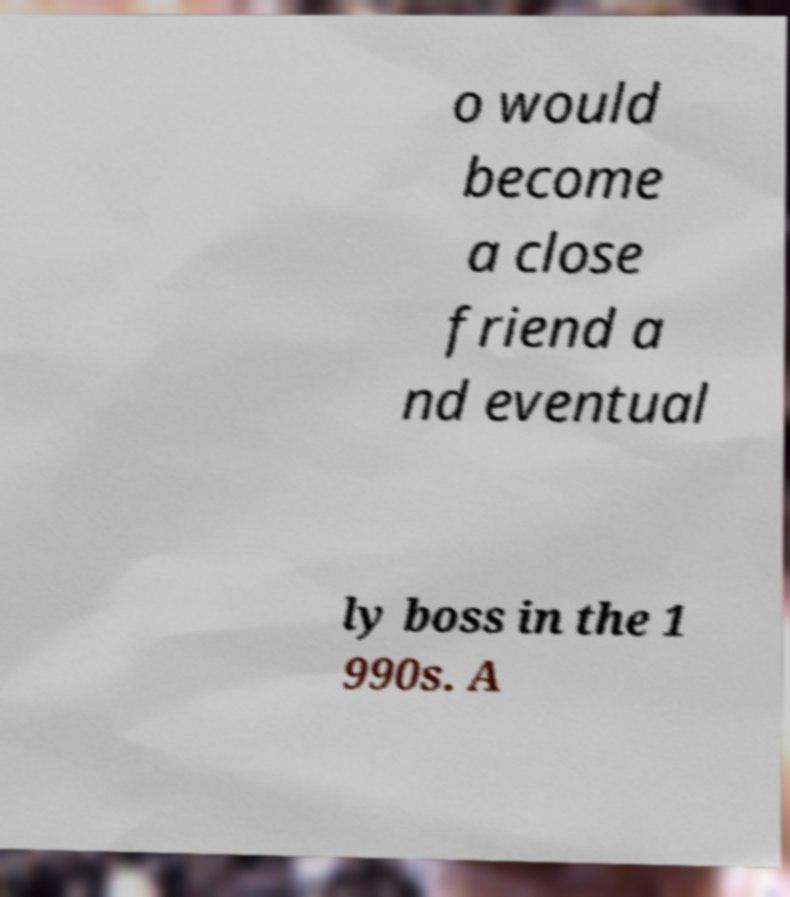Can you accurately transcribe the text from the provided image for me? o would become a close friend a nd eventual ly boss in the 1 990s. A 